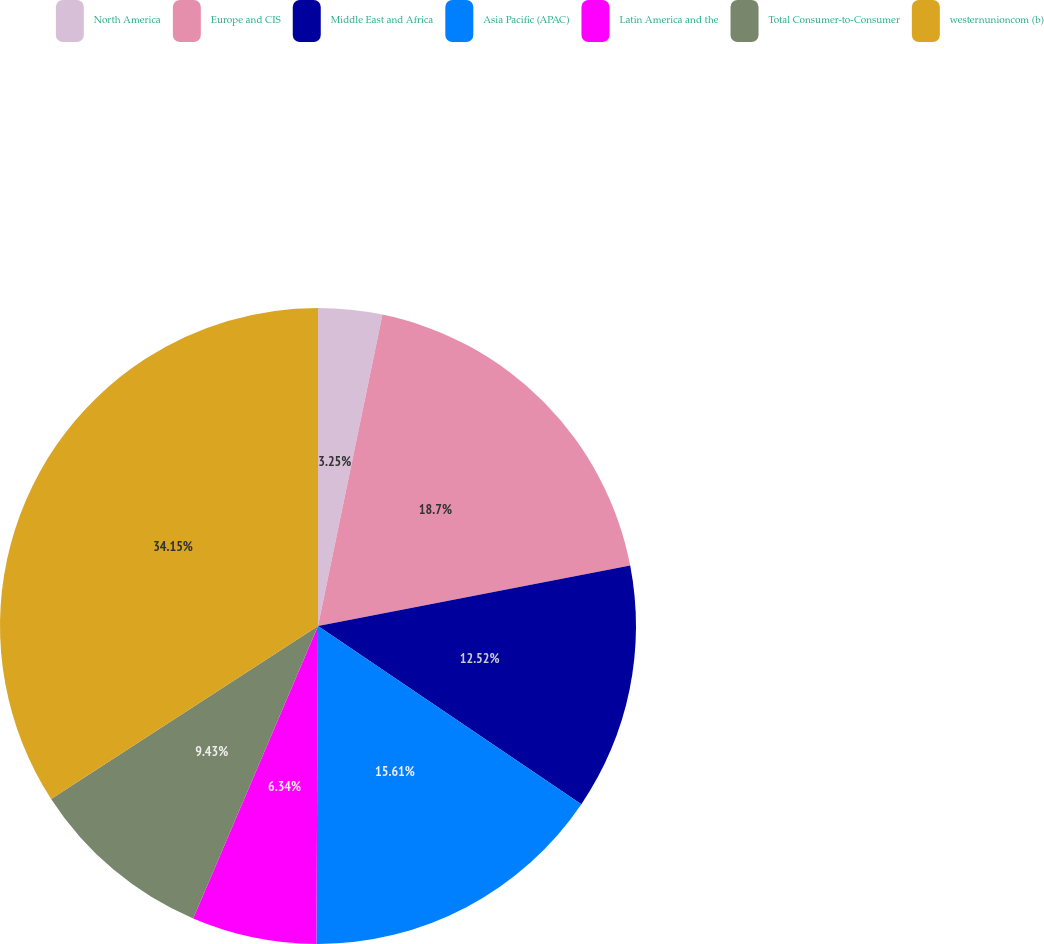Convert chart. <chart><loc_0><loc_0><loc_500><loc_500><pie_chart><fcel>North America<fcel>Europe and CIS<fcel>Middle East and Africa<fcel>Asia Pacific (APAC)<fcel>Latin America and the<fcel>Total Consumer-to-Consumer<fcel>westernunioncom (b)<nl><fcel>3.25%<fcel>18.7%<fcel>12.52%<fcel>15.61%<fcel>6.34%<fcel>9.43%<fcel>34.15%<nl></chart> 